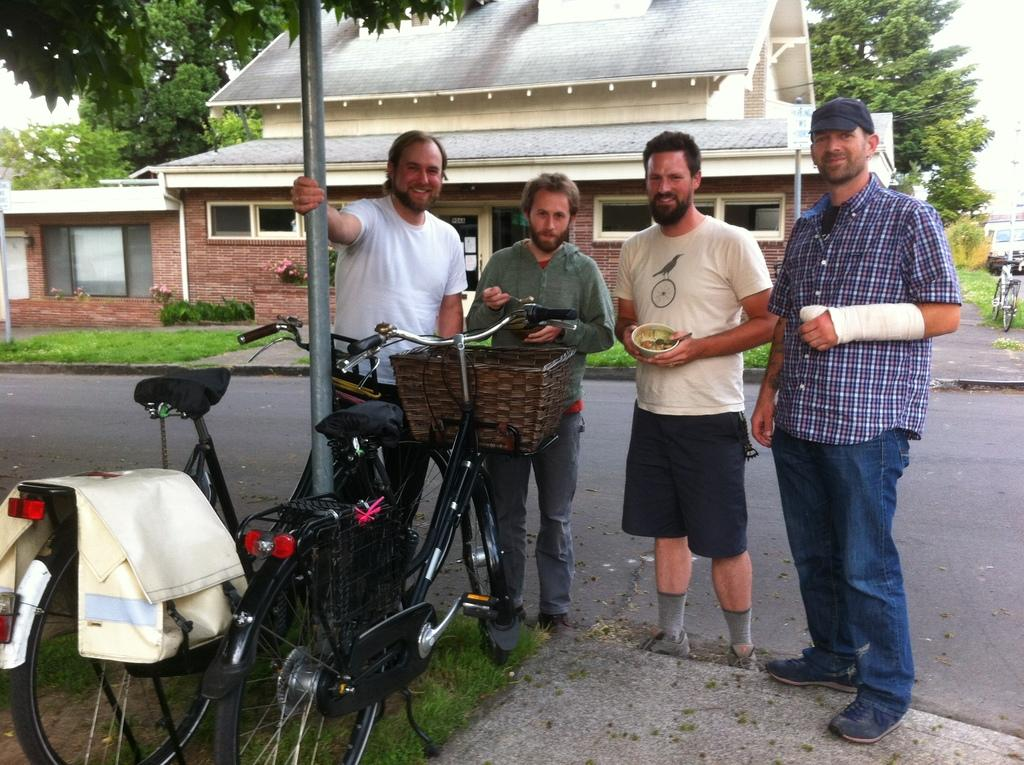How many people are in the image? There are four people standing in the center of the image. What can be seen on the left side of the image? There are two bicycles on the left side of the image. What is visible in the background of the image? There is a building and trees in the background of the image. What type of surface is visible at the bottom of the image? There is a road visible at the bottom of the image. What type of toothpaste is being used by the people in the image? There is no toothpaste present in the image; it features four people standing with two bicycles nearby. Can you see any jewels or crowns on the people in the image? There are no jewels or crowns visible on the people in the image. 